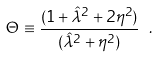<formula> <loc_0><loc_0><loc_500><loc_500>\Theta \equiv \frac { ( 1 + \hat { \lambda } ^ { 2 } + 2 \eta ^ { 2 } ) } { ( \hat { \lambda } ^ { 2 } + \eta ^ { 2 } ) } \ .</formula> 